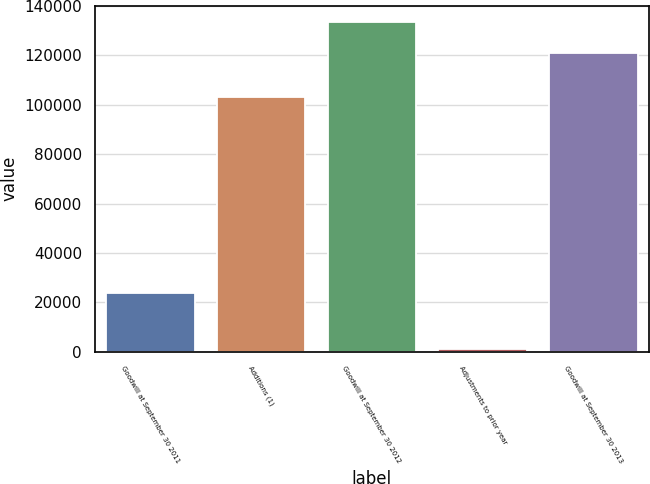Convert chart. <chart><loc_0><loc_0><loc_500><loc_500><bar_chart><fcel>Goodwill at September 30 2011<fcel>Additions (1)<fcel>Goodwill at September 30 2012<fcel>Adjustments to prior year<fcel>Goodwill at September 30 2013<nl><fcel>23827<fcel>102967<fcel>133477<fcel>1041<fcel>120902<nl></chart> 